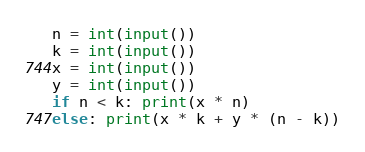Convert code to text. <code><loc_0><loc_0><loc_500><loc_500><_Python_>n = int(input())
k = int(input())
x = int(input())
y = int(input())
if n < k: print(x * n)
else: print(x * k + y * (n - k))</code> 